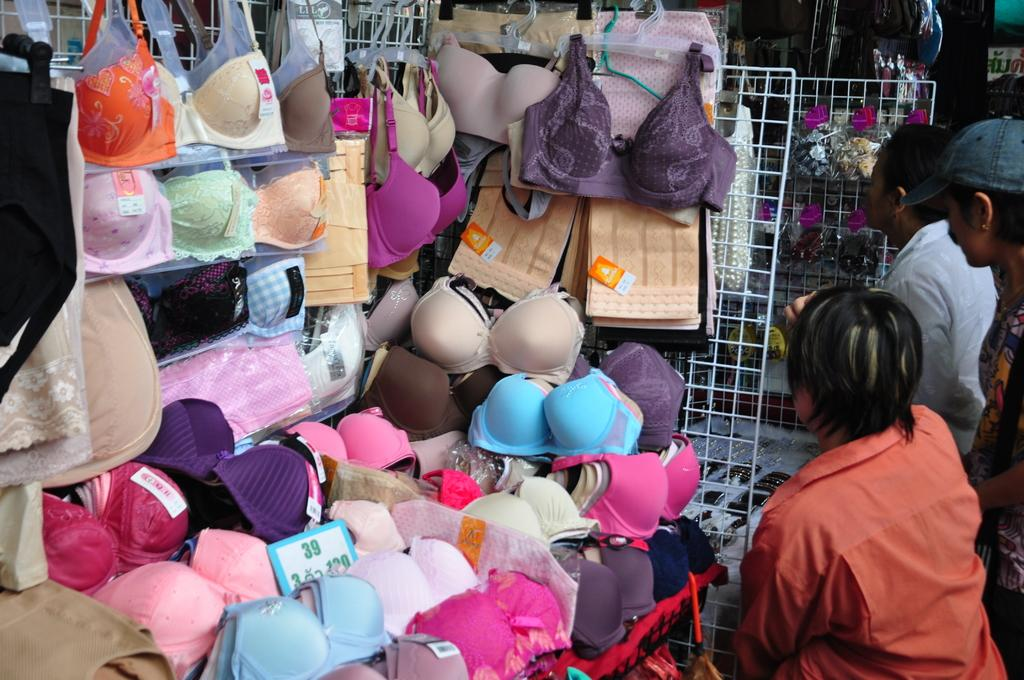What type of clothing item is located in the left corner of the image? There are inner wears in the left corner of the image. What is happening in the right corner of the image? There are persons standing in the right corner of the image. Can you describe the background of the image? There are other objects visible in the background of the image. What color is the owl in the image? There is no owl present in the image. What type of paint is being used by the persons in the image? There is no paint or painting activity depicted in the image. 